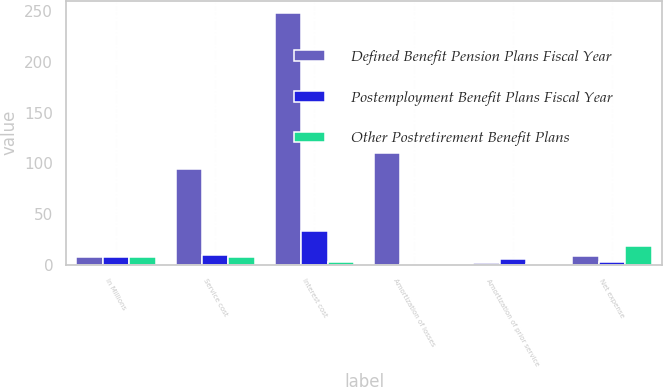Convert chart. <chart><loc_0><loc_0><loc_500><loc_500><stacked_bar_chart><ecel><fcel>In Millions<fcel>Service cost<fcel>Interest cost<fcel>Amortization of losses<fcel>Amortization of prior service<fcel>Net expense<nl><fcel>Defined Benefit Pension Plans Fiscal Year<fcel>7.6<fcel>94.6<fcel>248<fcel>109.8<fcel>1.5<fcel>8.4<nl><fcel>Postemployment Benefit Plans Fiscal Year<fcel>7.6<fcel>9.9<fcel>33.1<fcel>0.6<fcel>5.5<fcel>2.3<nl><fcel>Other Postretirement Benefit Plans<fcel>7.6<fcel>7.6<fcel>3<fcel>0.1<fcel>0.7<fcel>18.1<nl></chart> 